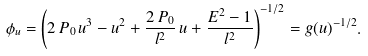<formula> <loc_0><loc_0><loc_500><loc_500>\phi _ { u } = \left ( 2 \, P _ { 0 } \, u ^ { 3 } - u ^ { 2 } + \frac { 2 \, P _ { 0 } } { l ^ { 2 } } \, u + \frac { E ^ { 2 } - 1 } { l ^ { 2 } } \right ) ^ { - 1 / 2 } = g ( u ) ^ { - 1 / 2 } .</formula> 